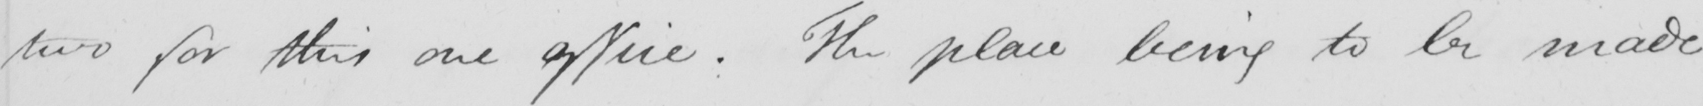Can you read and transcribe this handwriting? two for this one office . The place being to be made 